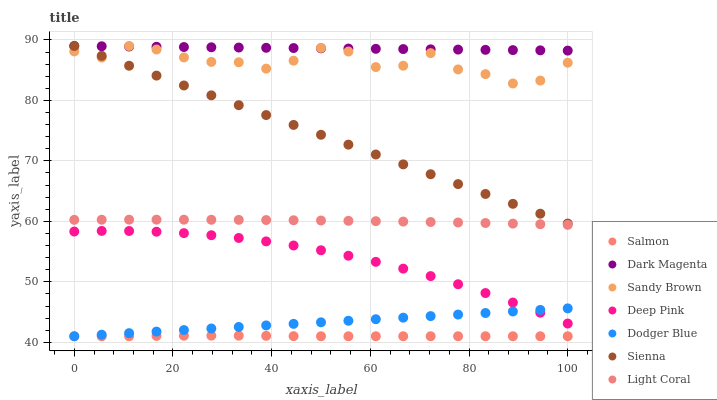Does Salmon have the minimum area under the curve?
Answer yes or no. Yes. Does Dark Magenta have the maximum area under the curve?
Answer yes or no. Yes. Does Deep Pink have the minimum area under the curve?
Answer yes or no. No. Does Deep Pink have the maximum area under the curve?
Answer yes or no. No. Is Dodger Blue the smoothest?
Answer yes or no. Yes. Is Sandy Brown the roughest?
Answer yes or no. Yes. Is Deep Pink the smoothest?
Answer yes or no. No. Is Deep Pink the roughest?
Answer yes or no. No. Does Salmon have the lowest value?
Answer yes or no. Yes. Does Deep Pink have the lowest value?
Answer yes or no. No. Does Sandy Brown have the highest value?
Answer yes or no. Yes. Does Deep Pink have the highest value?
Answer yes or no. No. Is Salmon less than Sienna?
Answer yes or no. Yes. Is Deep Pink greater than Salmon?
Answer yes or no. Yes. Does Deep Pink intersect Dodger Blue?
Answer yes or no. Yes. Is Deep Pink less than Dodger Blue?
Answer yes or no. No. Is Deep Pink greater than Dodger Blue?
Answer yes or no. No. Does Salmon intersect Sienna?
Answer yes or no. No. 